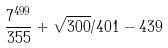Convert formula to latex. <formula><loc_0><loc_0><loc_500><loc_500>\frac { 7 ^ { 4 9 9 } } { 3 5 5 } + \sqrt { 3 0 0 } / 4 0 1 - 4 3 9</formula> 